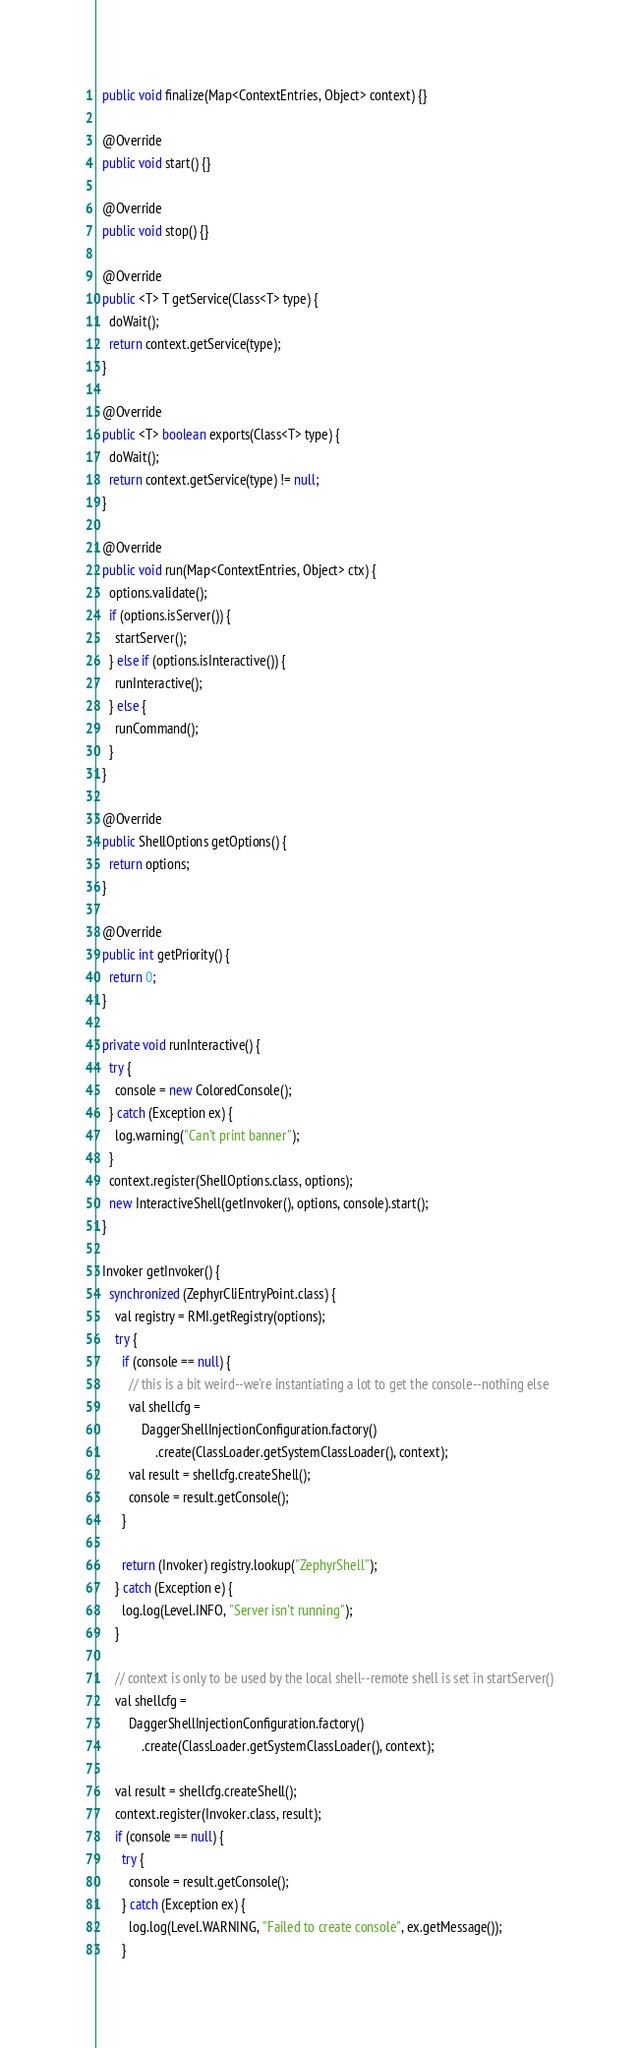Convert code to text. <code><loc_0><loc_0><loc_500><loc_500><_Java_>  public void finalize(Map<ContextEntries, Object> context) {}

  @Override
  public void start() {}

  @Override
  public void stop() {}

  @Override
  public <T> T getService(Class<T> type) {
    doWait();
    return context.getService(type);
  }

  @Override
  public <T> boolean exports(Class<T> type) {
    doWait();
    return context.getService(type) != null;
  }

  @Override
  public void run(Map<ContextEntries, Object> ctx) {
    options.validate();
    if (options.isServer()) {
      startServer();
    } else if (options.isInteractive()) {
      runInteractive();
    } else {
      runCommand();
    }
  }

  @Override
  public ShellOptions getOptions() {
    return options;
  }

  @Override
  public int getPriority() {
    return 0;
  }

  private void runInteractive() {
    try {
      console = new ColoredConsole();
    } catch (Exception ex) {
      log.warning("Can't print banner");
    }
    context.register(ShellOptions.class, options);
    new InteractiveShell(getInvoker(), options, console).start();
  }

  Invoker getInvoker() {
    synchronized (ZephyrCliEntryPoint.class) {
      val registry = RMI.getRegistry(options);
      try {
        if (console == null) {
          // this is a bit weird--we're instantiating a lot to get the console--nothing else
          val shellcfg =
              DaggerShellInjectionConfiguration.factory()
                  .create(ClassLoader.getSystemClassLoader(), context);
          val result = shellcfg.createShell();
          console = result.getConsole();
        }

        return (Invoker) registry.lookup("ZephyrShell");
      } catch (Exception e) {
        log.log(Level.INFO, "Server isn't running");
      }

      // context is only to be used by the local shell--remote shell is set in startServer()
      val shellcfg =
          DaggerShellInjectionConfiguration.factory()
              .create(ClassLoader.getSystemClassLoader(), context);

      val result = shellcfg.createShell();
      context.register(Invoker.class, result);
      if (console == null) {
        try {
          console = result.getConsole();
        } catch (Exception ex) {
          log.log(Level.WARNING, "Failed to create console", ex.getMessage());
        }</code> 